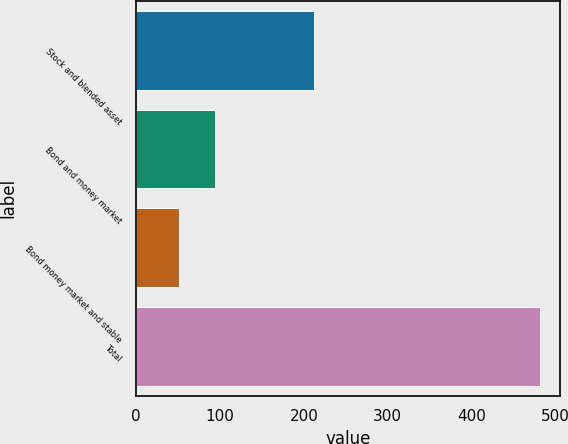<chart> <loc_0><loc_0><loc_500><loc_500><bar_chart><fcel>Stock and blended asset<fcel>Bond and money market<fcel>Bond money market and stable<fcel>Total<nl><fcel>212.4<fcel>94.28<fcel>51.2<fcel>482<nl></chart> 